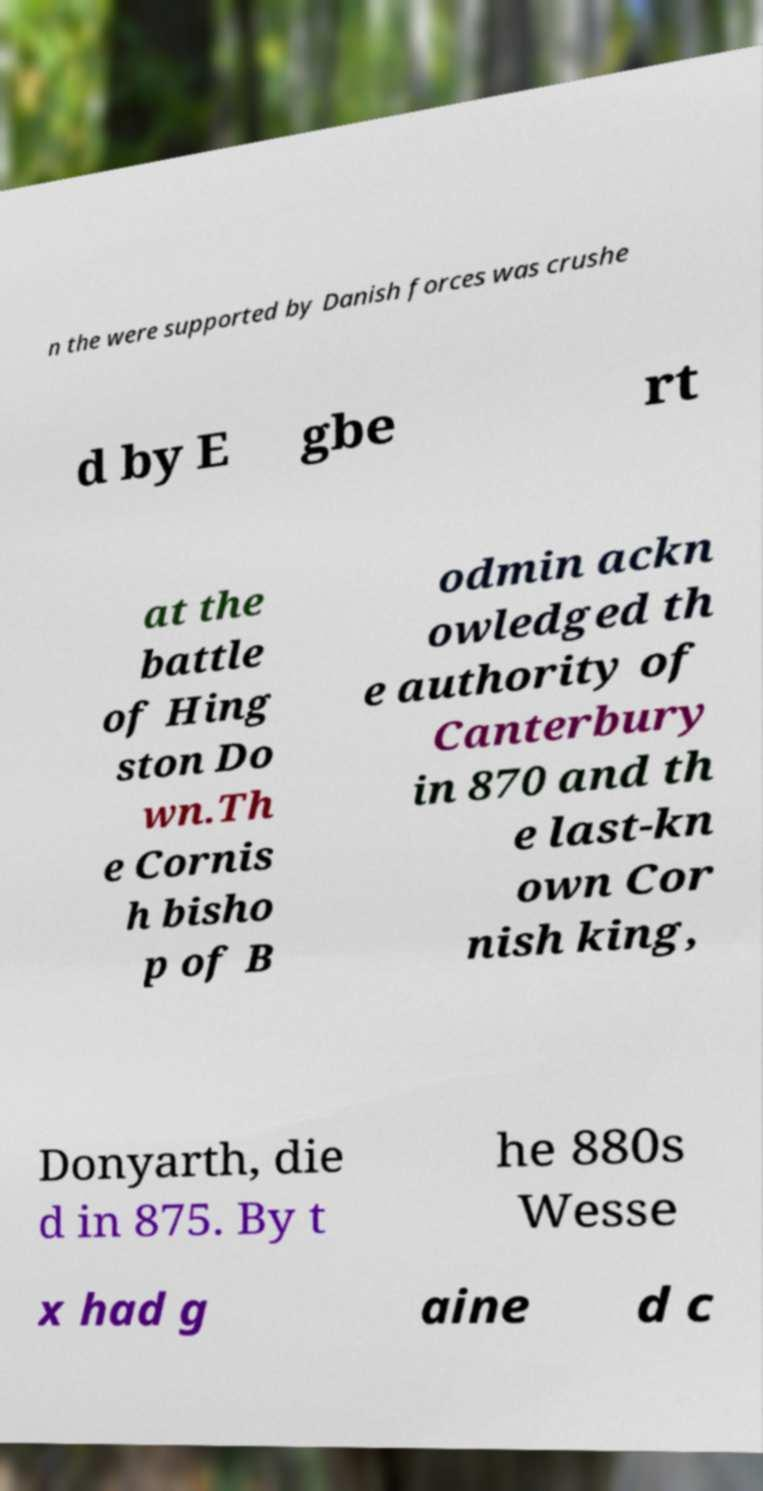Please identify and transcribe the text found in this image. n the were supported by Danish forces was crushe d by E gbe rt at the battle of Hing ston Do wn.Th e Cornis h bisho p of B odmin ackn owledged th e authority of Canterbury in 870 and th e last-kn own Cor nish king, Donyarth, die d in 875. By t he 880s Wesse x had g aine d c 